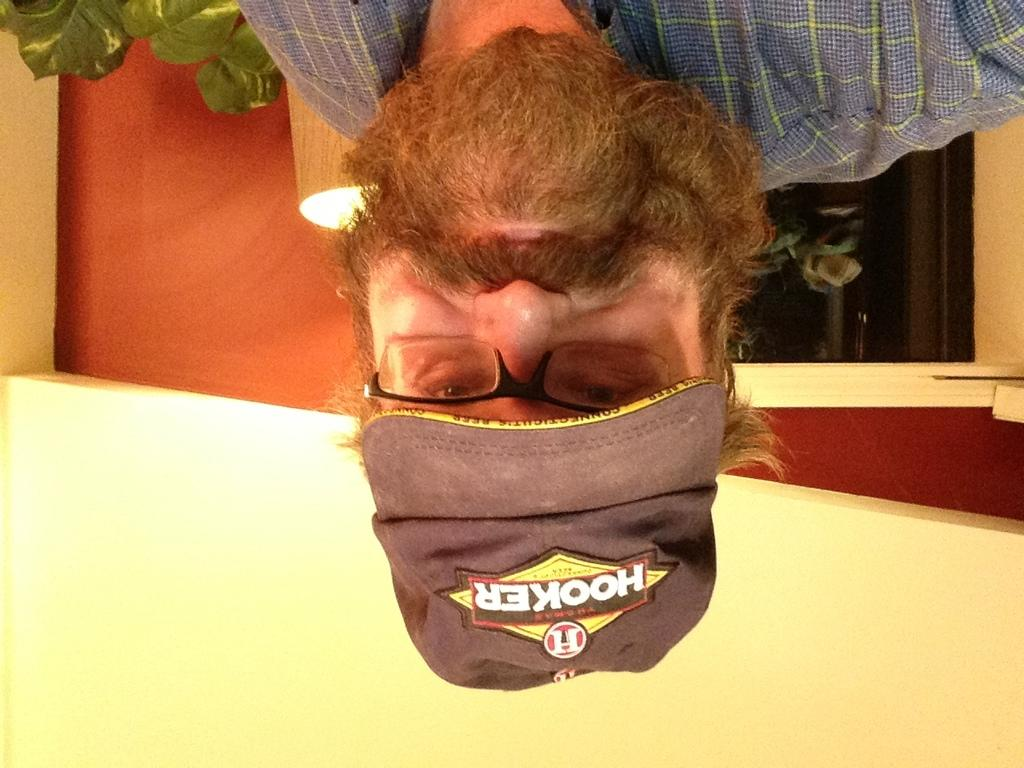Who is present in the image? There is a man in the image. What can be seen in the background of the image? There are walls, an electric light, and a plant in the background of the image. What type of hook is the man using to beginner his thrill in the image? There is no hook or thrill-seeking activity present in the image; it simply features a man and some background elements. 